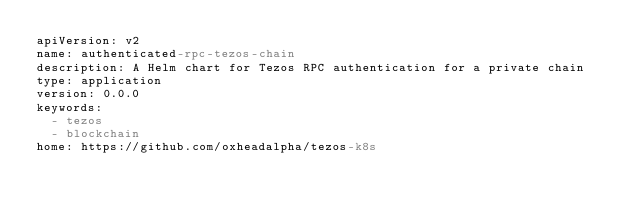<code> <loc_0><loc_0><loc_500><loc_500><_YAML_>apiVersion: v2
name: authenticated-rpc-tezos-chain
description: A Helm chart for Tezos RPC authentication for a private chain
type: application
version: 0.0.0
keywords:
  - tezos
  - blockchain
home: https://github.com/oxheadalpha/tezos-k8s
</code> 